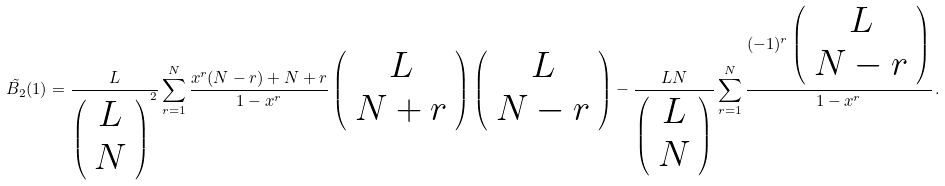Convert formula to latex. <formula><loc_0><loc_0><loc_500><loc_500>\tilde { B _ { 2 } } ( 1 ) = \frac { L } { \left ( \begin{array} { c } L \\ N \end{array} \right ) ^ { 2 } } \sum _ { r = 1 } ^ { N } \frac { x ^ { r } ( N - r ) + N + r } { 1 - x ^ { r } } \left ( \begin{array} { c } L \\ N + r \end{array} \right ) \left ( \begin{array} { c } L \\ N - r \end{array} \right ) - \frac { L N } { \left ( \begin{array} { c } L \\ N \end{array} \right ) } \sum _ { r = 1 } ^ { N } \frac { ( - 1 ) ^ { r } \left ( \begin{array} { c } L \\ N - r \end{array} \right ) } { 1 - x ^ { r } } \, .</formula> 